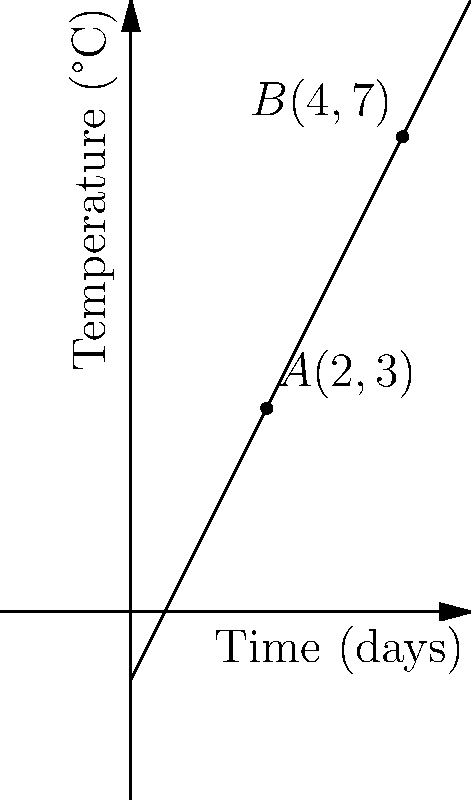Given the vector representation of temperature change over time, where point $A(2,3)$ represents the temperature after 2 days and point $B(4,7)$ represents the temperature after 4 days, calculate the rate of ice melt in °C per day. To calculate the rate of ice melt, we need to determine the change in temperature over time:

1. Calculate the change in temperature (ΔT):
   ΔT = Temperature at B - Temperature at A
   ΔT = 7°C - 3°C = 4°C

2. Calculate the change in time (Δt):
   Δt = Time at B - Time at A
   Δt = 4 days - 2 days = 2 days

3. Calculate the rate of ice melt (r) using the formula:
   $r = \frac{\text{change in temperature}}{\text{change in time}} = \frac{\Delta T}{\Delta t}$

4. Substitute the values:
   $r = \frac{4°C}{2 \text{ days}} = 2°C/\text{day}$

Therefore, the rate of ice melt is 2°C per day.
Answer: 2°C/day 